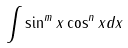<formula> <loc_0><loc_0><loc_500><loc_500>\int \sin ^ { m } x \cos ^ { n } x d x</formula> 